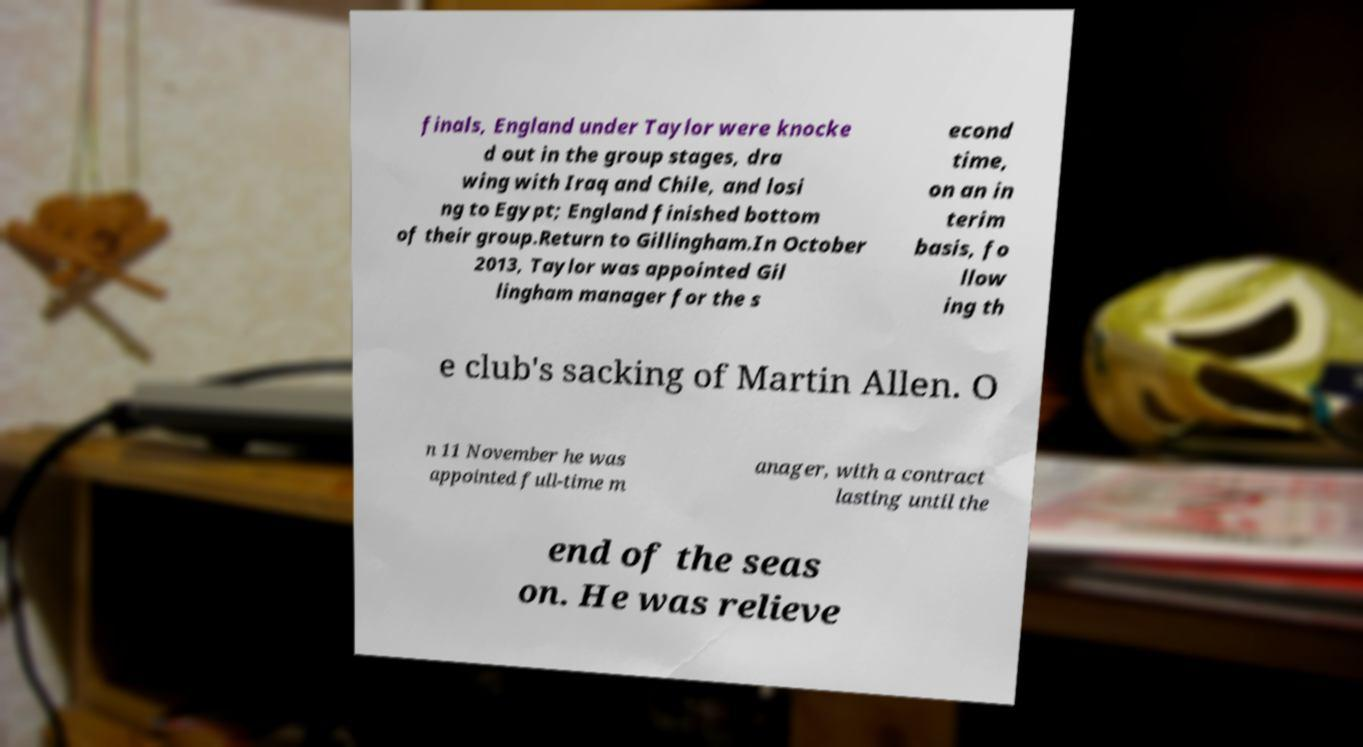Could you extract and type out the text from this image? finals, England under Taylor were knocke d out in the group stages, dra wing with Iraq and Chile, and losi ng to Egypt; England finished bottom of their group.Return to Gillingham.In October 2013, Taylor was appointed Gil lingham manager for the s econd time, on an in terim basis, fo llow ing th e club's sacking of Martin Allen. O n 11 November he was appointed full-time m anager, with a contract lasting until the end of the seas on. He was relieve 